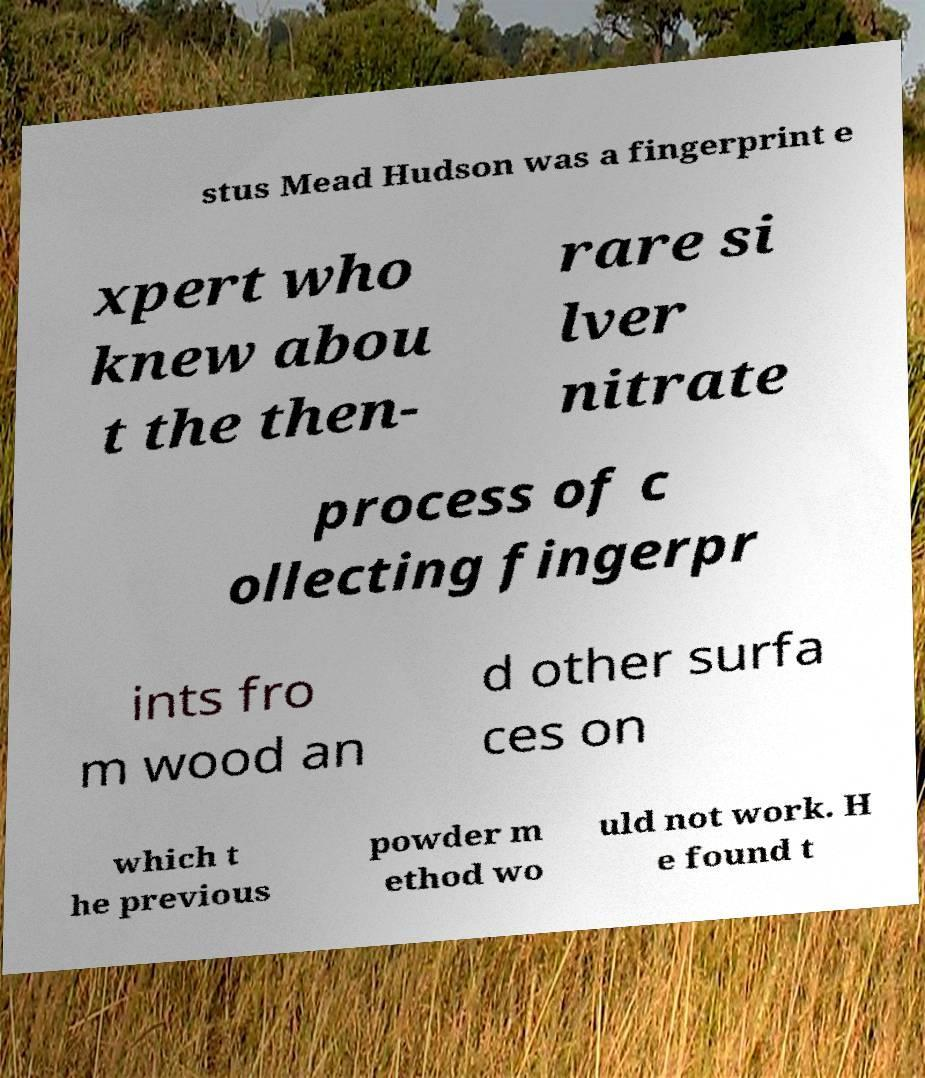Could you extract and type out the text from this image? stus Mead Hudson was a fingerprint e xpert who knew abou t the then- rare si lver nitrate process of c ollecting fingerpr ints fro m wood an d other surfa ces on which t he previous powder m ethod wo uld not work. H e found t 